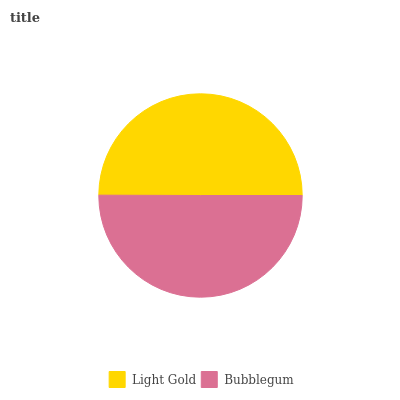Is Light Gold the minimum?
Answer yes or no. Yes. Is Bubblegum the maximum?
Answer yes or no. Yes. Is Bubblegum the minimum?
Answer yes or no. No. Is Bubblegum greater than Light Gold?
Answer yes or no. Yes. Is Light Gold less than Bubblegum?
Answer yes or no. Yes. Is Light Gold greater than Bubblegum?
Answer yes or no. No. Is Bubblegum less than Light Gold?
Answer yes or no. No. Is Bubblegum the high median?
Answer yes or no. Yes. Is Light Gold the low median?
Answer yes or no. Yes. Is Light Gold the high median?
Answer yes or no. No. Is Bubblegum the low median?
Answer yes or no. No. 